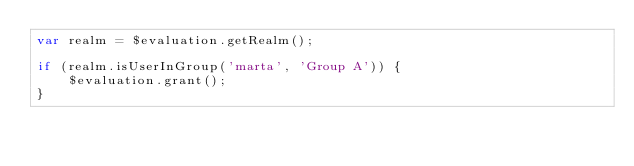Convert code to text. <code><loc_0><loc_0><loc_500><loc_500><_JavaScript_>var realm = $evaluation.getRealm();

if (realm.isUserInGroup('marta', 'Group A')) {
    $evaluation.grant();
}
</code> 